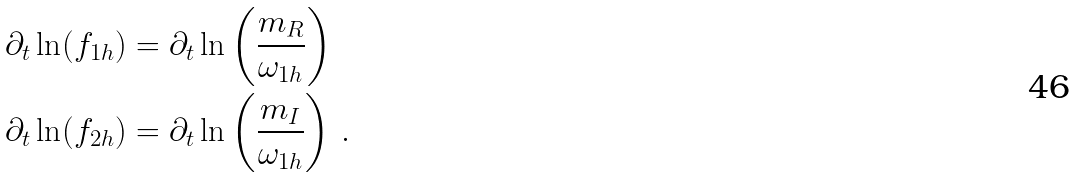<formula> <loc_0><loc_0><loc_500><loc_500>\partial _ { t } \ln ( f _ { 1 h } ) & = \partial _ { t } \ln \left ( \frac { m _ { R } } { \omega _ { 1 h } } \right ) \\ \partial _ { t } \ln ( f _ { 2 h } ) & = \partial _ { t } \ln \left ( \frac { m _ { I } } { \omega _ { 1 h } } \right ) \, .</formula> 